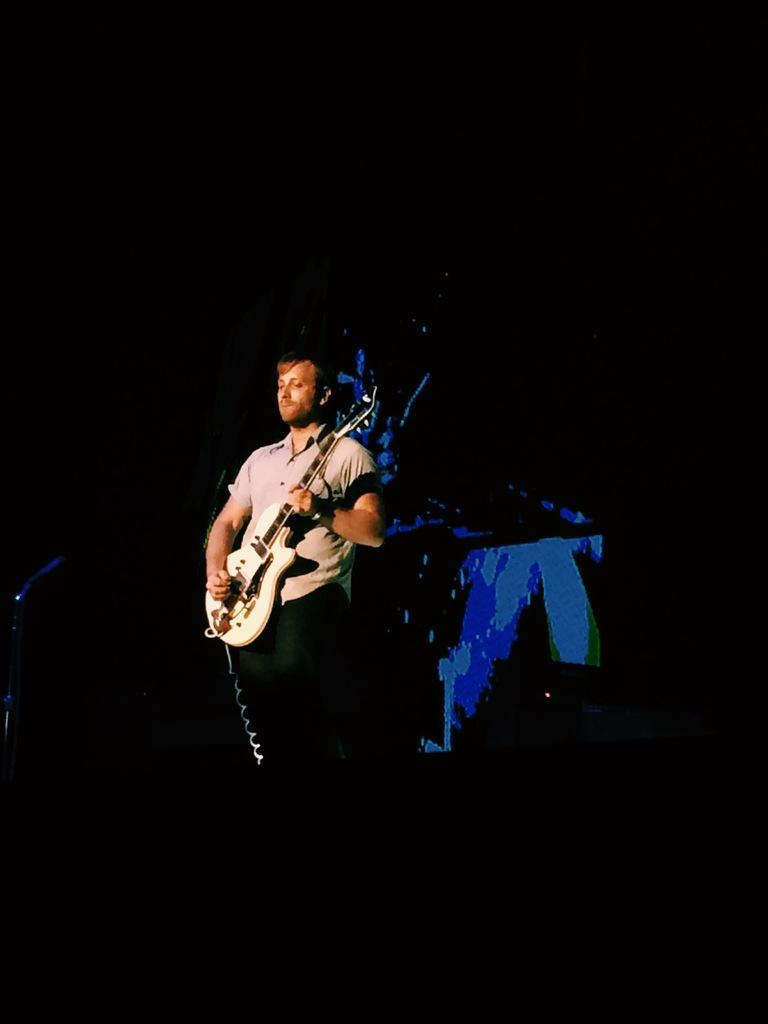Could you give a brief overview of what you see in this image? In this image we can see a person standing and playing a guitar and the background is dark. 